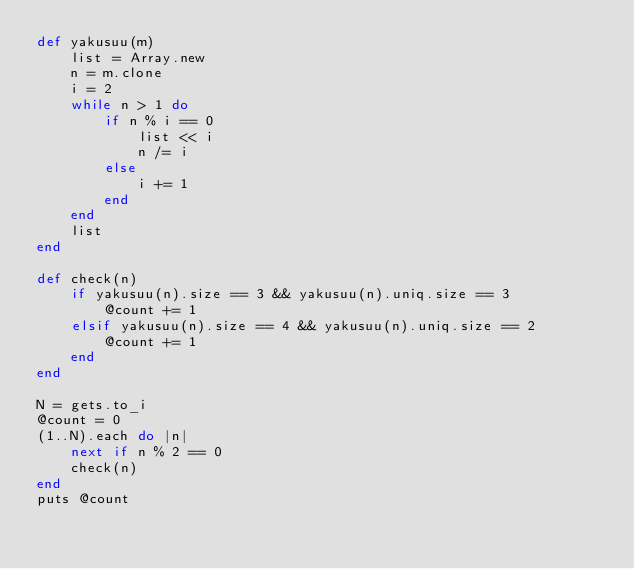Convert code to text. <code><loc_0><loc_0><loc_500><loc_500><_Ruby_>def yakusuu(m)
    list = Array.new
    n = m.clone
    i = 2
    while n > 1 do
        if n % i == 0
            list << i
            n /= i
        else
            i += 1
        end
    end
    list
end

def check(n)
    if yakusuu(n).size == 3 && yakusuu(n).uniq.size == 3
        @count += 1
    elsif yakusuu(n).size == 4 && yakusuu(n).uniq.size == 2
        @count += 1
    end
end

N = gets.to_i
@count = 0
(1..N).each do |n|
    next if n % 2 == 0
    check(n)
end
puts @count</code> 